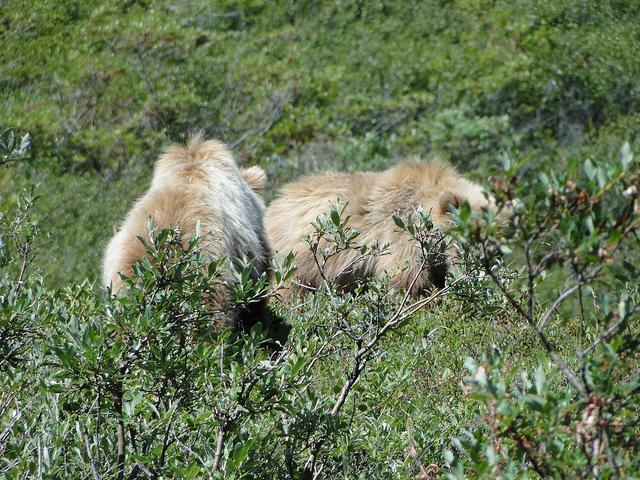How many animals are in the photo?
Give a very brief answer. 2. How many bears are there?
Give a very brief answer. 2. 